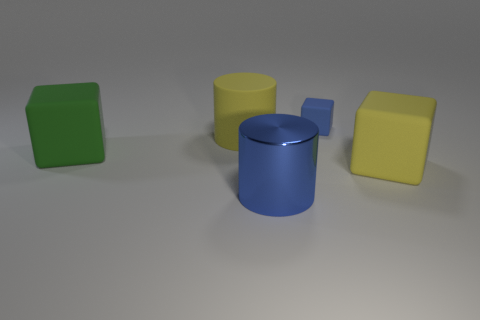There is a yellow thing that is the same shape as the tiny blue thing; what is its size?
Your response must be concise. Large. There is a blue thing that is behind the blue object to the left of the blue rubber object; what shape is it?
Offer a very short reply. Cube. There is a block that is the same color as the shiny cylinder; what is its material?
Offer a terse response. Rubber. There is a tiny object that is made of the same material as the yellow cylinder; what color is it?
Provide a short and direct response. Blue. Is there any other thing that is the same size as the blue matte thing?
Offer a very short reply. No. There is a cylinder that is behind the large green matte block; is its color the same as the large matte cube right of the big yellow cylinder?
Ensure brevity in your answer.  Yes. Is the number of big rubber things to the left of the metallic cylinder greater than the number of big green cubes behind the tiny blue cube?
Your response must be concise. Yes. There is another large thing that is the same shape as the blue metallic object; what color is it?
Offer a very short reply. Yellow. There is a big green rubber object; does it have the same shape as the yellow matte thing behind the green cube?
Provide a succinct answer. No. How many other objects are there of the same material as the large yellow cube?
Provide a succinct answer. 3. 